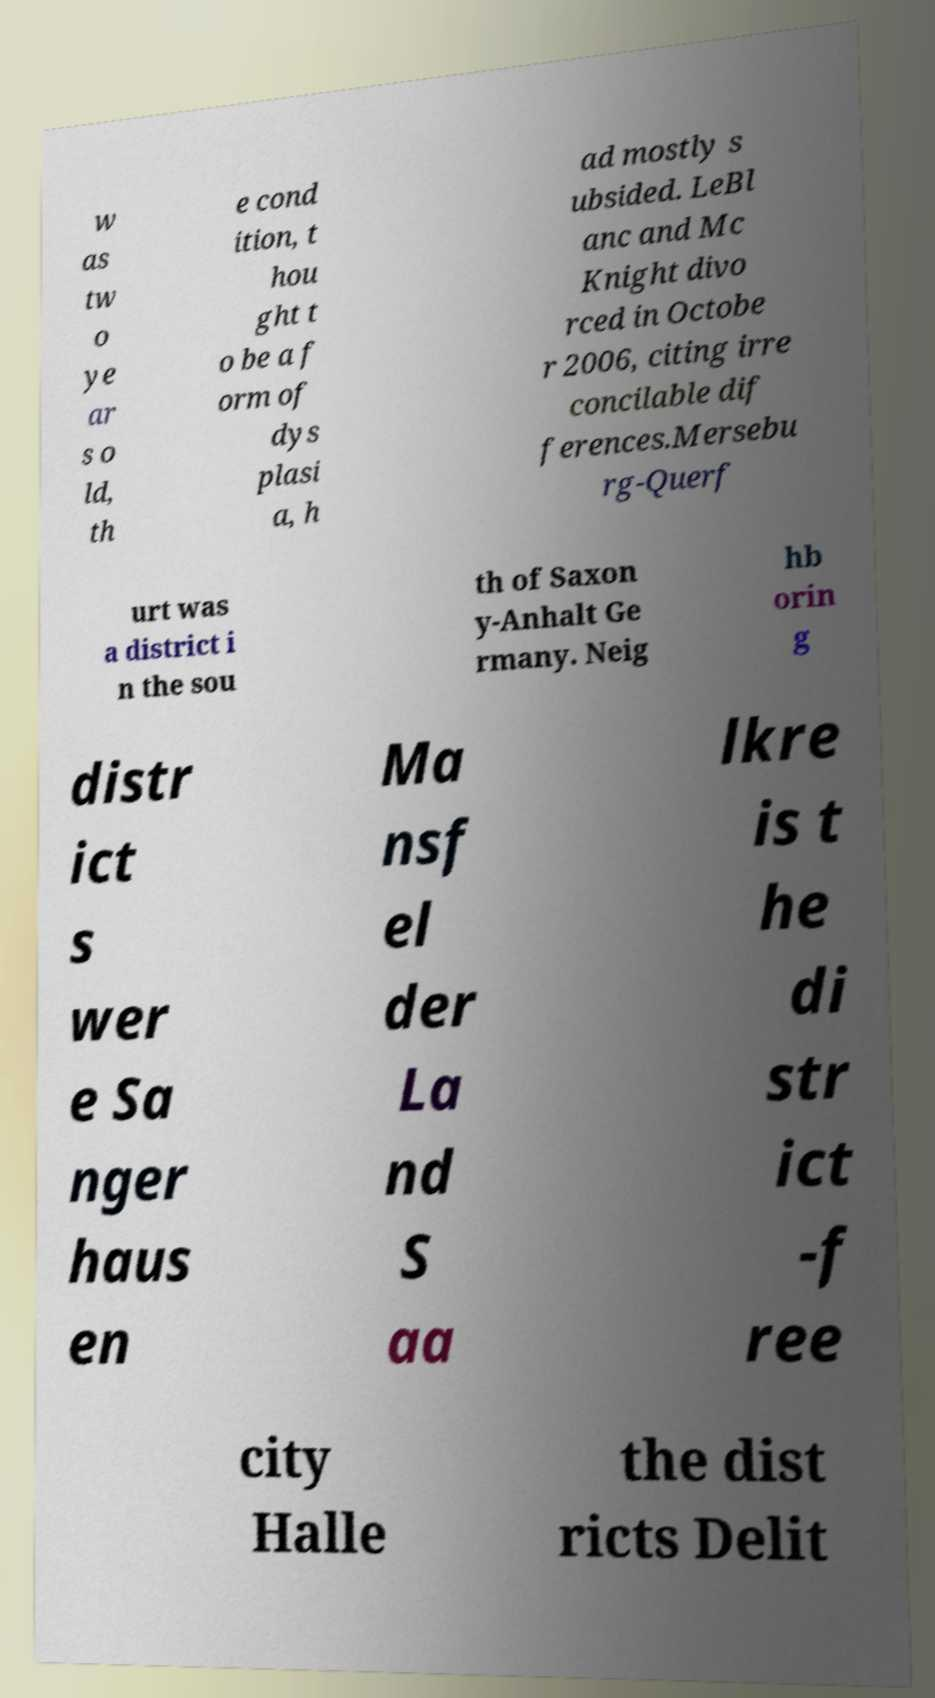Could you extract and type out the text from this image? w as tw o ye ar s o ld, th e cond ition, t hou ght t o be a f orm of dys plasi a, h ad mostly s ubsided. LeBl anc and Mc Knight divo rced in Octobe r 2006, citing irre concilable dif ferences.Mersebu rg-Querf urt was a district i n the sou th of Saxon y-Anhalt Ge rmany. Neig hb orin g distr ict s wer e Sa nger haus en Ma nsf el der La nd S aa lkre is t he di str ict -f ree city Halle the dist ricts Delit 